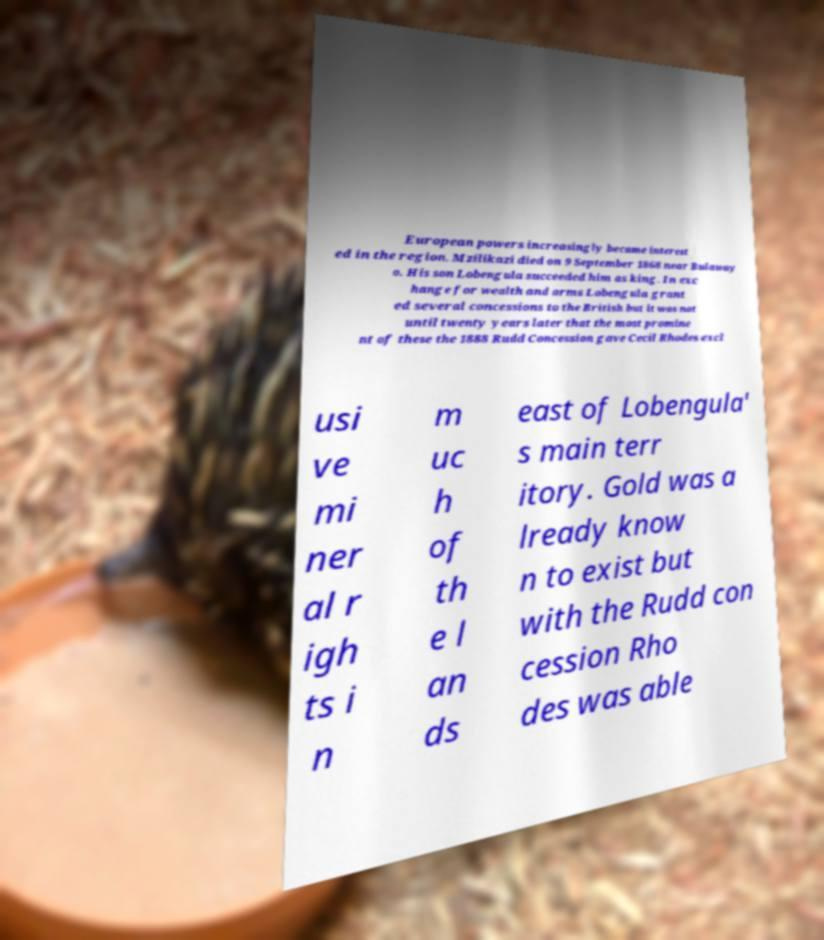There's text embedded in this image that I need extracted. Can you transcribe it verbatim? European powers increasingly became interest ed in the region. Mzilikazi died on 9 September 1868 near Bulaway o. His son Lobengula succeeded him as king. In exc hange for wealth and arms Lobengula grant ed several concessions to the British but it was not until twenty years later that the most promine nt of these the 1888 Rudd Concession gave Cecil Rhodes excl usi ve mi ner al r igh ts i n m uc h of th e l an ds east of Lobengula' s main terr itory. Gold was a lready know n to exist but with the Rudd con cession Rho des was able 